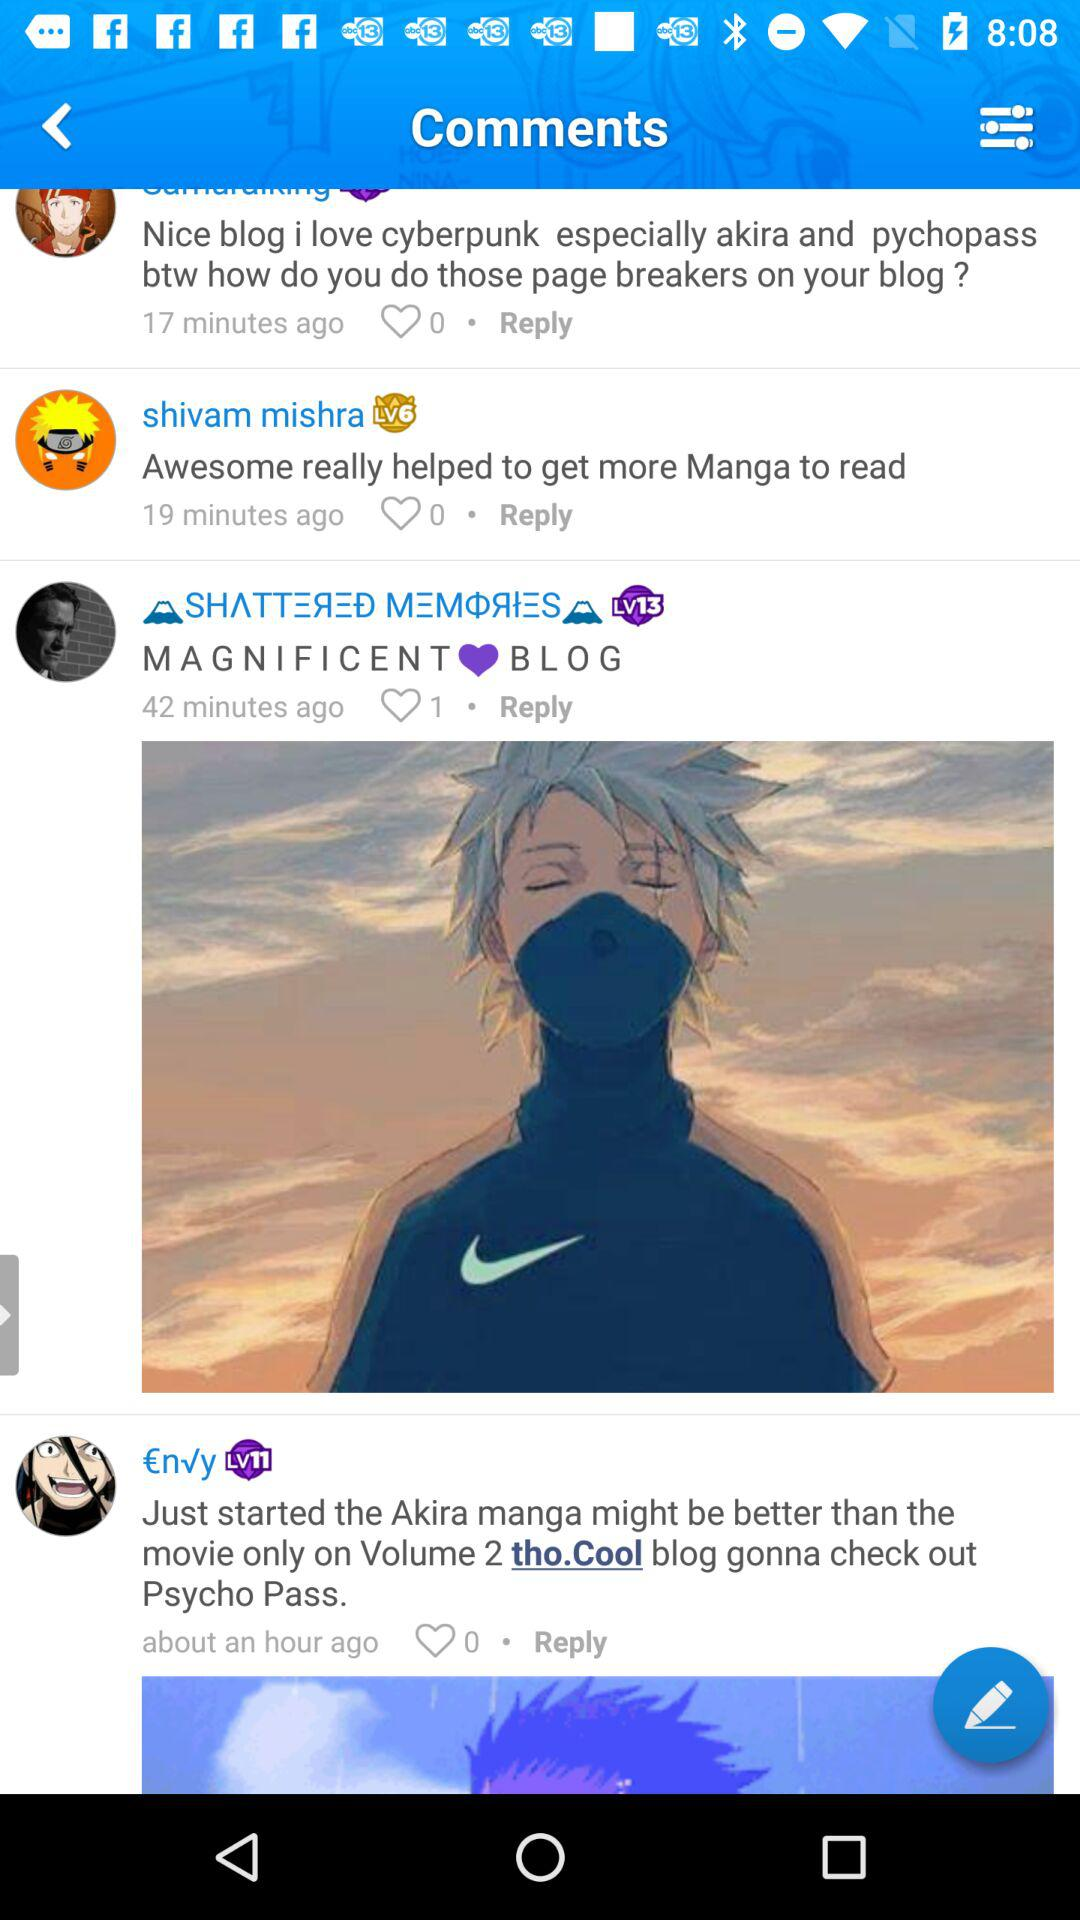How many comments are on the blog?
Answer the question using a single word or phrase. 4 